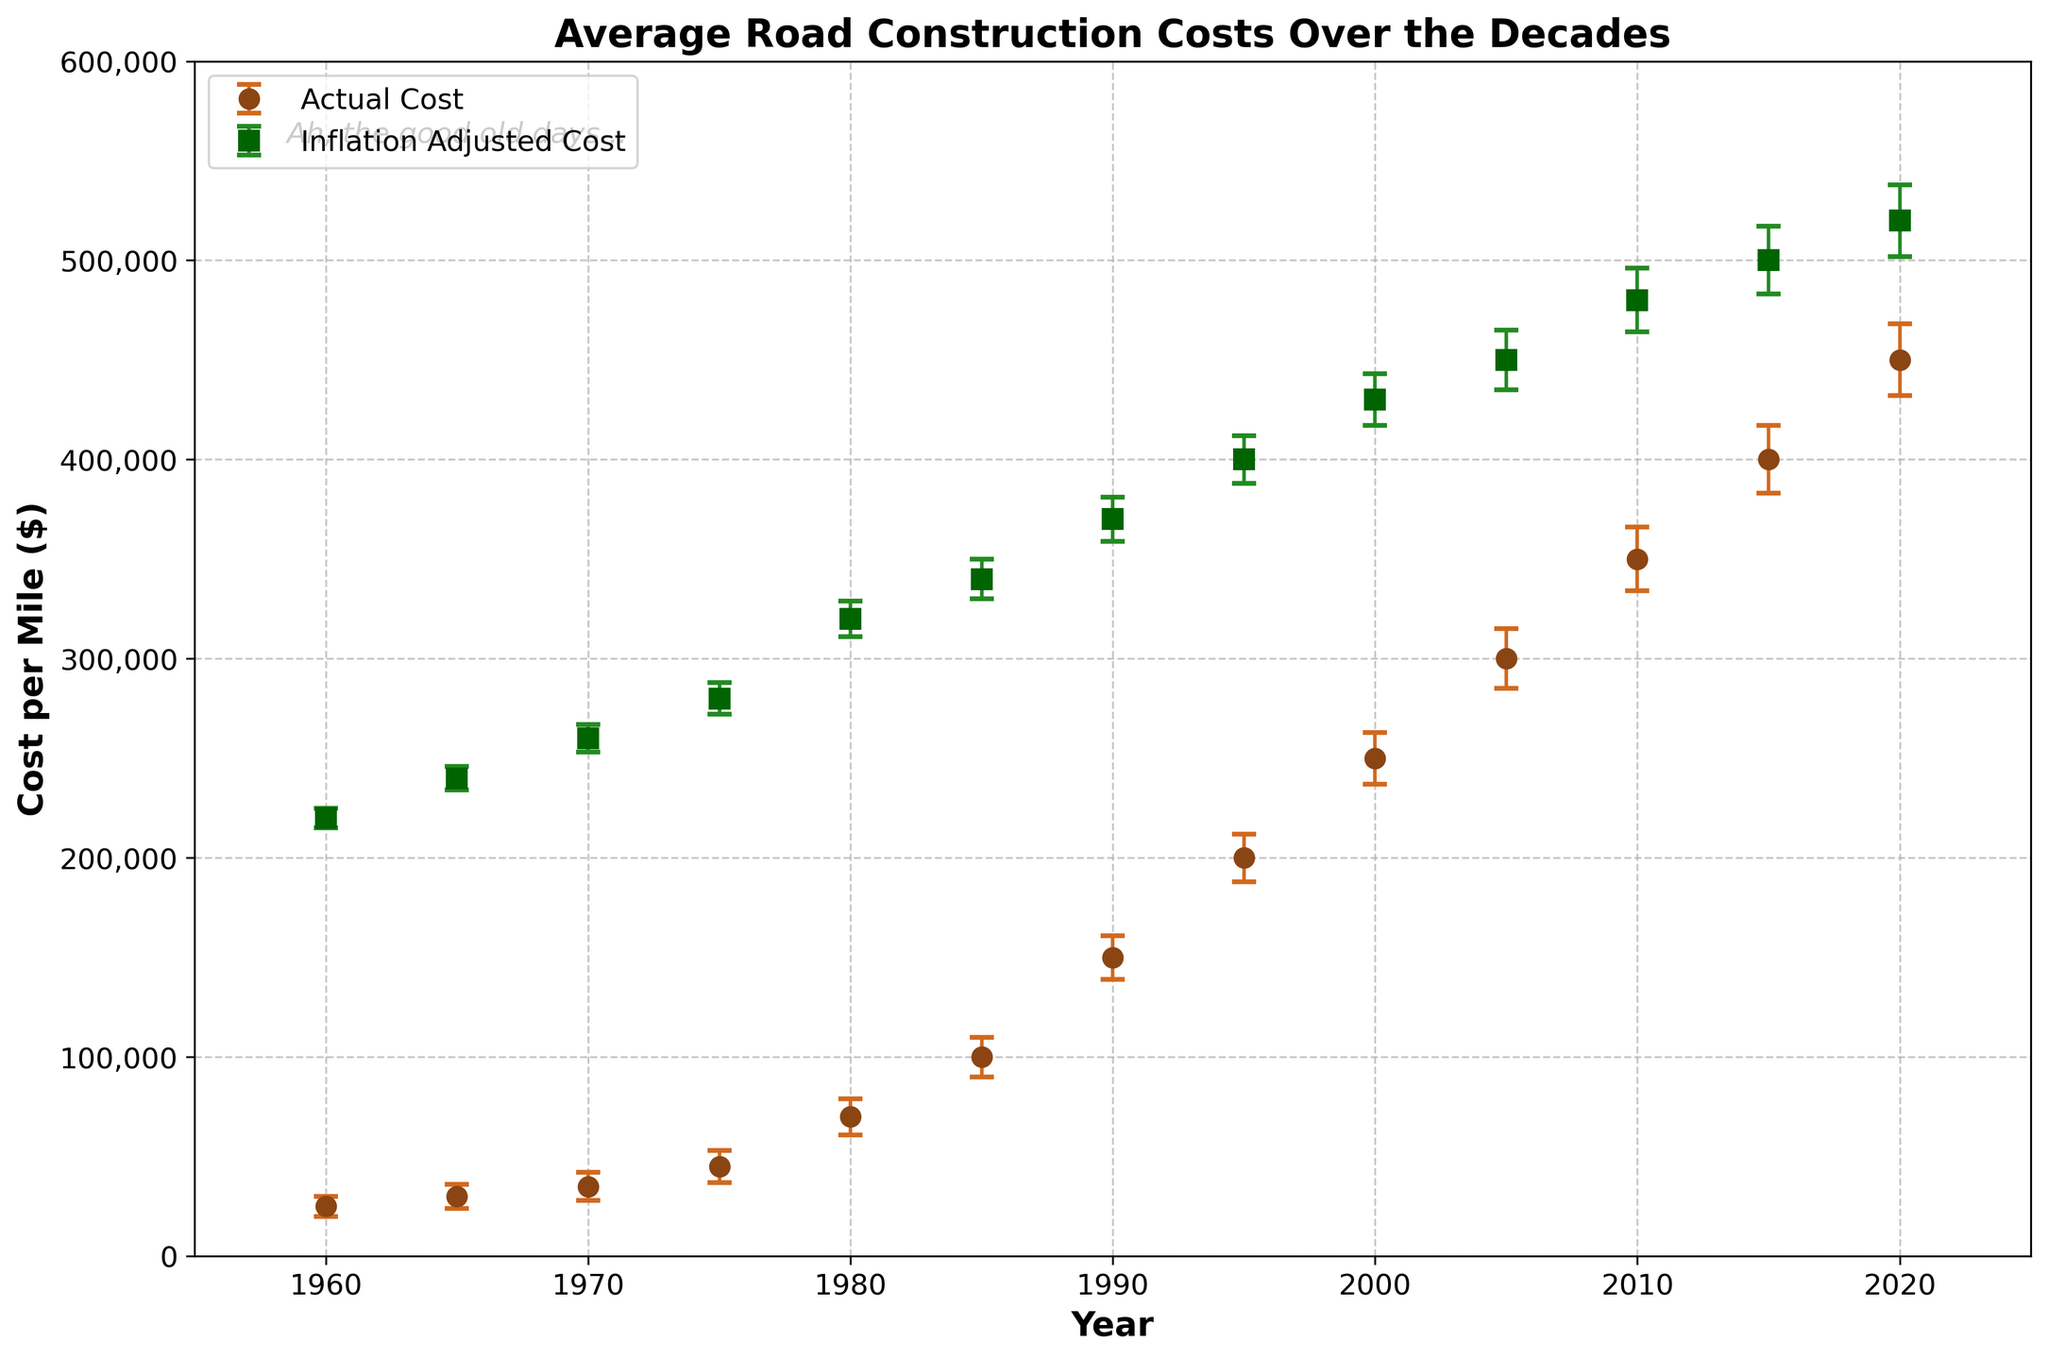What is the title of the figure? The title is typically located at the top of the figure in larger and bold font. Here, it is "Average Road Construction Costs Over the Decades".
Answer: Average Road Construction Costs Over the Decades What do the markers 'o' and 's' represent in the plot? The legend on the left side of the plot indicates that the 'o' markers represent Actual Cost, while the 's' markers represent Inflation Adjusted Cost.
Answer: 'o' - Actual Cost, 's' - Inflation Adjusted Cost What is the average construction cost per mile in 1985? Locate the data point for 1985 on the x-axis and find the corresponding y-value for cost. It is $100,000.
Answer: $100,000 How does the inflation-adjusted cost per mile in 1990 compare to that in 1960? Find the y-values for the inflation-adjusted costs in both years. In 1960, it's $220,000, and in 1990, it's $370,000. 370,000 is larger than 220,000.
Answer: Inflation-adjusted cost in 1990 is higher than in 1960 What is the error range (error bars) for the actual cost in 1975? The standard error for 1975 is 8,000, so the error range is $45,000 ± $8,000, which means $37,000 to $53,000.
Answer: $37,000 to $53,000 Between which two consecutive years does the inflation-adjusted cost see the highest increase? Compare the inflation-adjusted costs year by year: the highest increase is between 1975 and 1980 ($280,000 to $320,000, an increase of $40,000).
Answer: 1975 and 1980 What is the inflation-adjusted cost per mile in the year 2000? Locate the data point for 2000 on the x-axis and find the corresponding y-value for the inflation-adjusted cost. It is $430,000.
Answer: $430,000 By how much did the average cost per mile increase from 1960 to 2020 in actual dollars? Subtract the 1960 average cost ($25,000) from the 2020 average cost ($450,000). The increase is $425,000.
Answer: $425,000 Are there any years where the standard error bars for cost overlap? Compare the error bars visually across years. For example, in 2020, the high-end of the error bar at $468,000 can overlap with the low-end of a nearby year's error bar.
Answer: Yes, there are overlaps What time period shows the most dramatic rise in the average cost per mile? Look for the steepest slope in the actual cost line. The most dramatic rise appears between 1975 and 1990, where the slope is steepest.
Answer: 1975-1990 